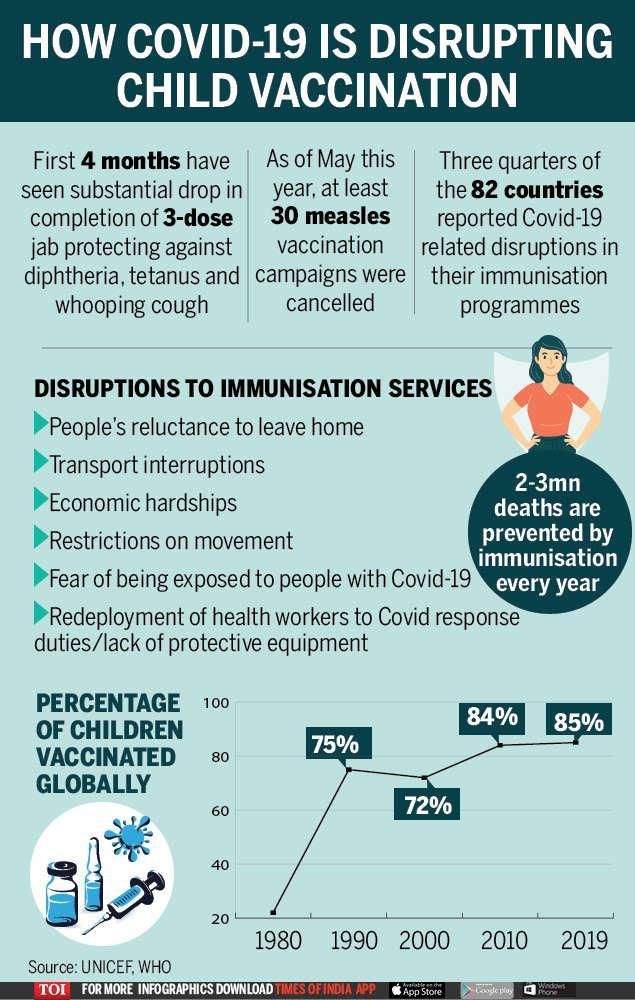Around which year was there a slight drop in the percentage of children vaccinated globally?
Answer the question with a short phrase. 2000 What is the number of fatalities that are avoided by timely immunisation each year? 2-3mn deaths Which campaigns were cancelled? measles vaccination How many reasons are listed for disruption in immunisation service? 6 What is listed third as a reason for disrupting vaccination services? economic hardships From which diseases does the 3-dose jab offer protection against? diphtheria, tetanus and whooping cough As per the infographic, what was disrupted or delayed due to restrictions on movement? immunisation services What is the fifth reason given for disruption in vaccination services? Fear of being exposed to people with Covid-19 